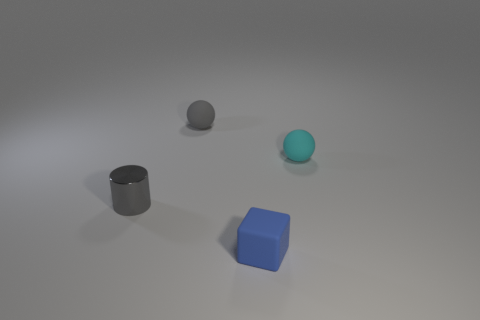Are there any other things of the same color as the metal thing?
Your answer should be compact. Yes. There is a tiny blue object that is the same material as the small gray sphere; what shape is it?
Your answer should be very brief. Cube. What is the color of the ball on the right side of the object that is in front of the gray metallic cylinder that is in front of the gray matte sphere?
Your answer should be very brief. Cyan. Are there an equal number of gray metallic cylinders on the left side of the tiny cylinder and large yellow matte cylinders?
Your answer should be very brief. Yes. Are there any other things that are made of the same material as the cylinder?
Make the answer very short. No. There is a tiny cylinder; does it have the same color as the rubber object on the left side of the tiny blue matte cube?
Provide a short and direct response. Yes. There is a gray object that is behind the sphere that is right of the gray ball; are there any small gray objects in front of it?
Your answer should be very brief. Yes. Is the number of cubes that are in front of the small blue object less than the number of tiny cylinders?
Your answer should be very brief. Yes. How many other objects are the same shape as the blue matte thing?
Your answer should be compact. 0. How many things are either small matte things behind the small metal thing or rubber things in front of the small cyan ball?
Give a very brief answer. 3. 